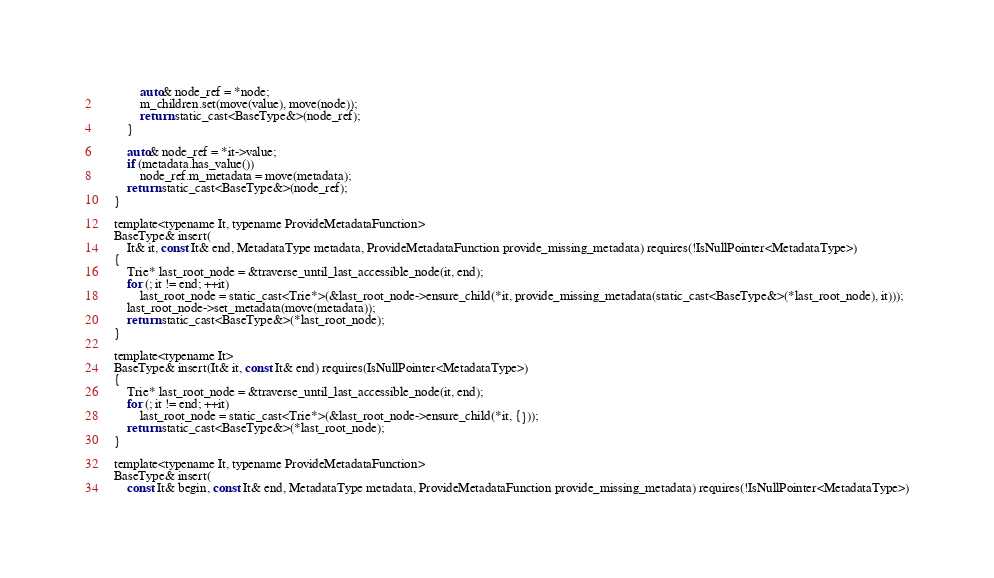Convert code to text. <code><loc_0><loc_0><loc_500><loc_500><_C_>            auto& node_ref = *node;
            m_children.set(move(value), move(node));
            return static_cast<BaseType&>(node_ref);
        }

        auto& node_ref = *it->value;
        if (metadata.has_value())
            node_ref.m_metadata = move(metadata);
        return static_cast<BaseType&>(node_ref);
    }

    template<typename It, typename ProvideMetadataFunction>
    BaseType& insert(
        It& it, const It& end, MetadataType metadata, ProvideMetadataFunction provide_missing_metadata) requires(!IsNullPointer<MetadataType>)
    {
        Trie* last_root_node = &traverse_until_last_accessible_node(it, end);
        for (; it != end; ++it)
            last_root_node = static_cast<Trie*>(&last_root_node->ensure_child(*it, provide_missing_metadata(static_cast<BaseType&>(*last_root_node), it)));
        last_root_node->set_metadata(move(metadata));
        return static_cast<BaseType&>(*last_root_node);
    }

    template<typename It>
    BaseType& insert(It& it, const It& end) requires(IsNullPointer<MetadataType>)
    {
        Trie* last_root_node = &traverse_until_last_accessible_node(it, end);
        for (; it != end; ++it)
            last_root_node = static_cast<Trie*>(&last_root_node->ensure_child(*it, {}));
        return static_cast<BaseType&>(*last_root_node);
    }

    template<typename It, typename ProvideMetadataFunction>
    BaseType& insert(
        const It& begin, const It& end, MetadataType metadata, ProvideMetadataFunction provide_missing_metadata) requires(!IsNullPointer<MetadataType>)</code> 